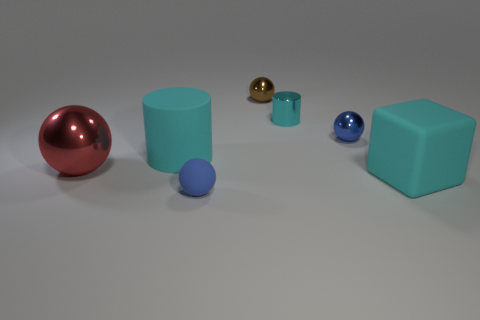Subtract all blue matte spheres. How many spheres are left? 3 Subtract all brown balls. How many balls are left? 3 Subtract all yellow balls. Subtract all red cylinders. How many balls are left? 4 Add 1 blue things. How many objects exist? 8 Subtract all blocks. How many objects are left? 6 Add 6 tiny gray metal things. How many tiny gray metal things exist? 6 Subtract 1 brown spheres. How many objects are left? 6 Subtract all large cyan objects. Subtract all big metal objects. How many objects are left? 4 Add 6 matte cylinders. How many matte cylinders are left? 7 